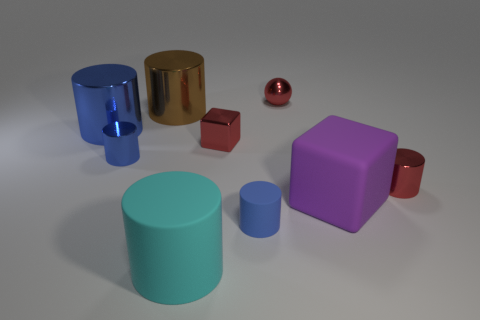Subtract all blue matte cylinders. How many cylinders are left? 5 Subtract all cyan cylinders. How many cylinders are left? 5 Subtract 1 spheres. How many spheres are left? 0 Subtract all cylinders. How many objects are left? 3 Subtract all red balls. How many blue cylinders are left? 3 Add 2 big blocks. How many big blocks are left? 3 Add 3 tiny red shiny spheres. How many tiny red shiny spheres exist? 4 Subtract 1 cyan cylinders. How many objects are left? 8 Subtract all yellow cylinders. Subtract all red balls. How many cylinders are left? 6 Subtract all large blue rubber cylinders. Subtract all big purple matte objects. How many objects are left? 8 